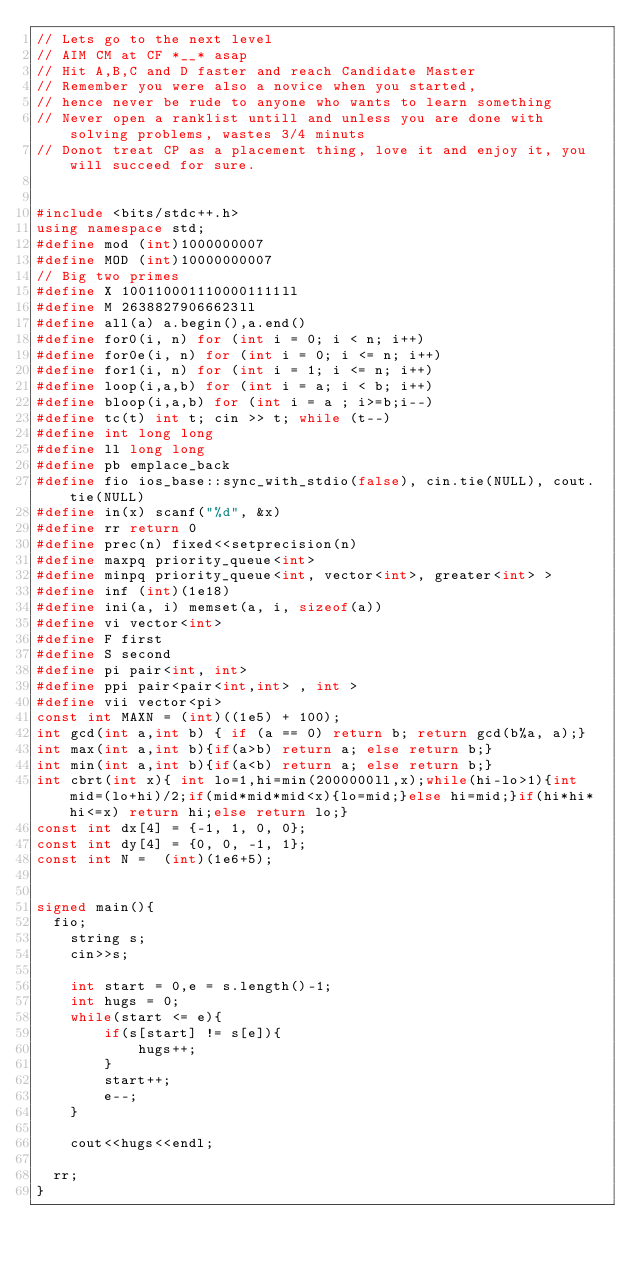<code> <loc_0><loc_0><loc_500><loc_500><_C++_>// Lets go to the next level 
// AIM CM at CF *__* asap 
// Hit A,B,C and D faster and reach Candidate Master
// Remember you were also a novice when you started, 
// hence never be rude to anyone who wants to learn something
// Never open a ranklist untill and unless you are done with solving problems, wastes 3/4 minuts 
// Donot treat CP as a placement thing, love it and enjoy it, you will succeed for sure.  


#include <bits/stdc++.h>
using namespace std;
#define mod (int)1000000007
#define MOD (int)10000000007
// Big two primes 
#define X 1001100011100001111ll
#define M 26388279066623ll
#define all(a) a.begin(),a.end()
#define for0(i, n) for (int i = 0; i < n; i++)
#define for0e(i, n) for (int i = 0; i <= n; i++)
#define for1(i, n) for (int i = 1; i <= n; i++)
#define loop(i,a,b) for (int i = a; i < b; i++)
#define bloop(i,a,b) for (int i = a ; i>=b;i--)
#define tc(t) int t; cin >> t; while (t--)
#define int long long 
#define ll long long
#define pb emplace_back
#define fio ios_base::sync_with_stdio(false), cin.tie(NULL), cout.tie(NULL)
#define in(x) scanf("%d", &x)
#define rr return 0
#define prec(n) fixed<<setprecision(n)
#define maxpq priority_queue<int>
#define minpq priority_queue<int, vector<int>, greater<int> >
#define inf (int)(1e18)
#define ini(a, i) memset(a, i, sizeof(a))
#define vi vector<int> 
#define F first
#define S second
#define pi pair<int, int>
#define ppi pair<pair<int,int> , int >
#define vii vector<pi>
const int MAXN = (int)((1e5) + 100);
int gcd(int a,int b) { if (a == 0) return b; return gcd(b%a, a);}
int max(int a,int b){if(a>b) return a; else return b;}
int min(int a,int b){if(a<b) return a; else return b;}  
int cbrt(int x){ int lo=1,hi=min(2000000ll,x);while(hi-lo>1){int mid=(lo+hi)/2;if(mid*mid*mid<x){lo=mid;}else hi=mid;}if(hi*hi*hi<=x) return hi;else return lo;} 
const int dx[4] = {-1, 1, 0, 0};
const int dy[4] = {0, 0, -1, 1};
const int N =  (int)(1e6+5); 


signed main(){
  fio;
    string s;
    cin>>s;

    int start = 0,e = s.length()-1;
    int hugs = 0;
    while(start <= e){
        if(s[start] != s[e]){
            hugs++;
        }
        start++;
        e--;
    }

    cout<<hugs<<endl;

  rr;
}</code> 